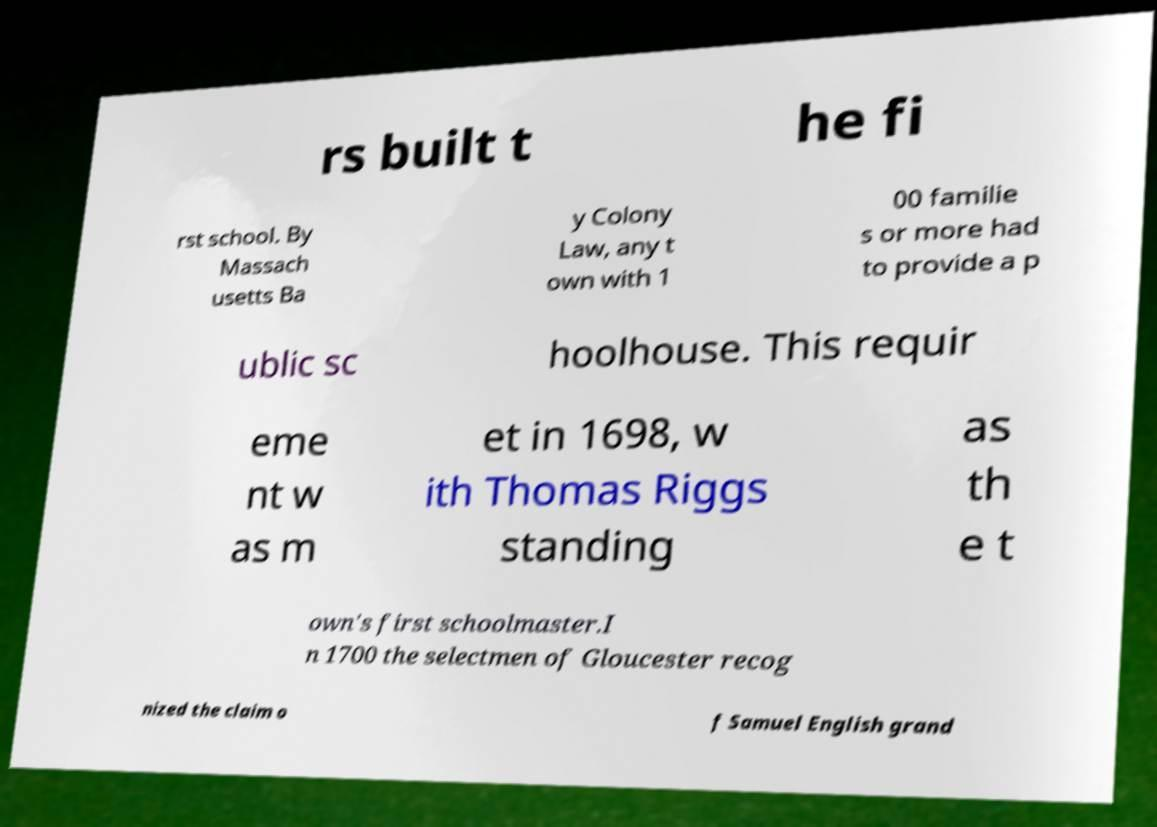Please read and relay the text visible in this image. What does it say? rs built t he fi rst school. By Massach usetts Ba y Colony Law, any t own with 1 00 familie s or more had to provide a p ublic sc hoolhouse. This requir eme nt w as m et in 1698, w ith Thomas Riggs standing as th e t own's first schoolmaster.I n 1700 the selectmen of Gloucester recog nized the claim o f Samuel English grand 